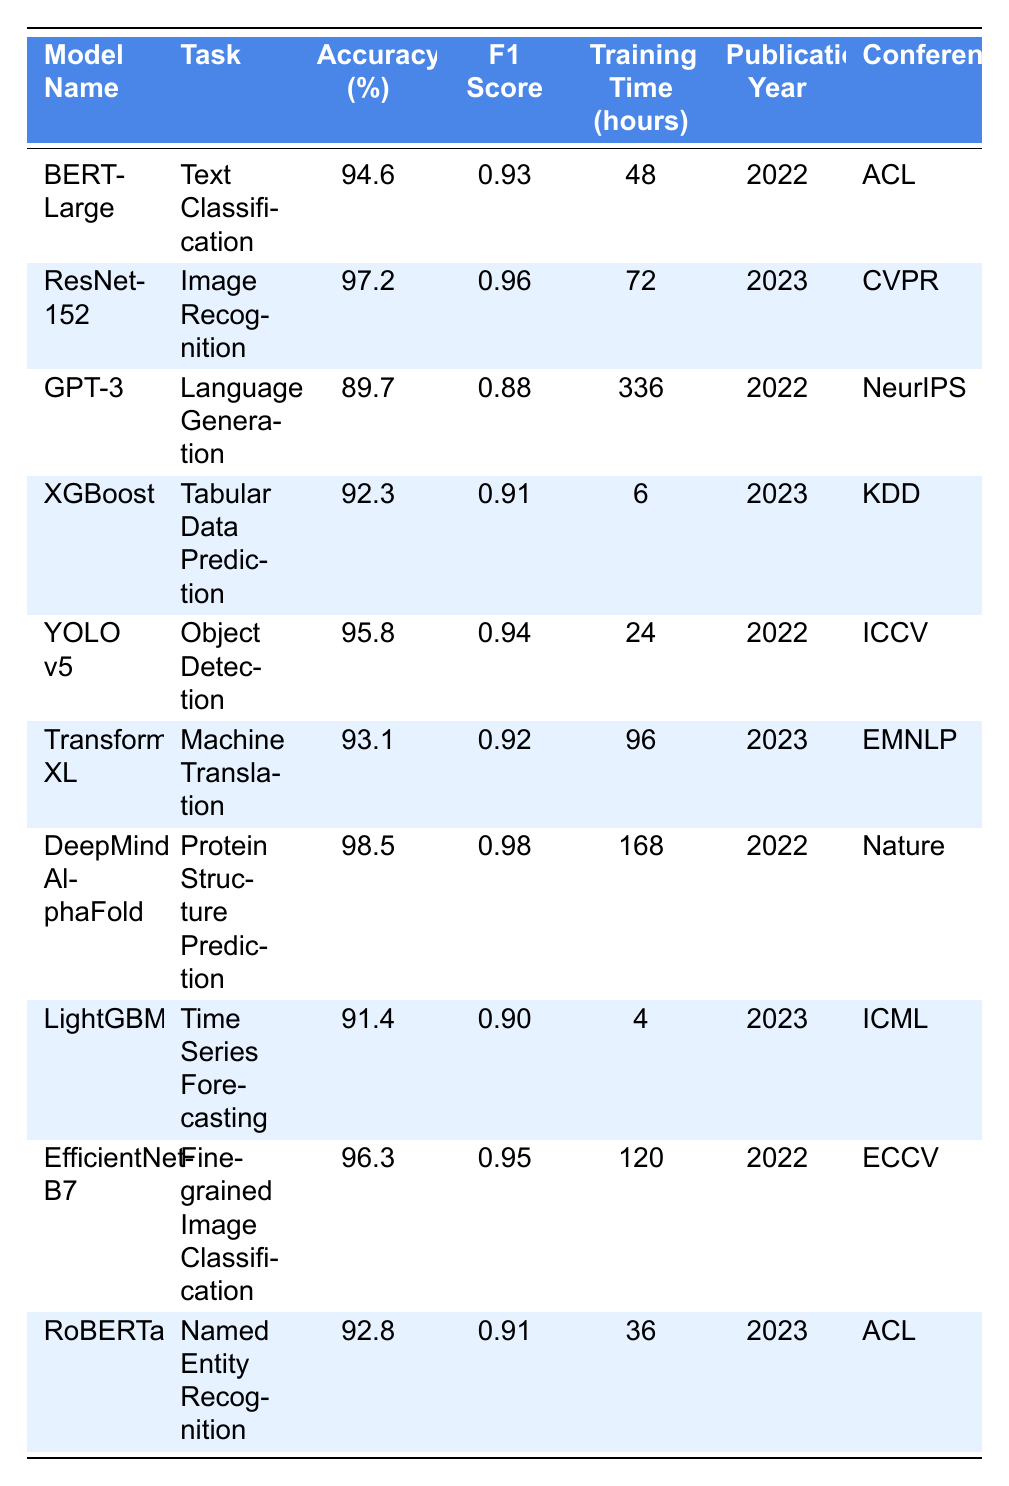What model had the highest accuracy? The models listed in the table are compared by their accuracy values. DeepMind AlphaFold has an accuracy of 98.5%, which is higher than all other models.
Answer: DeepMind AlphaFold Which model took the longest time to train? Training times for each model are compared, and GPT-3 has the highest training time at 336 hours.
Answer: GPT-3 Is ResNet-152 from a conference or journal? We look at the "Conference/Journal" column for ResNet-152, which lists CVPR, confirming it comes from a conference.
Answer: Yes What is the average F1 Score of the models used for tasks published in 2023? We find the F1 Scores for the 2023 publications: 0.96 (ResNet-152), 0.91 (XGBoost), 0.92 (Transformer-XL), and 0.91 (RoBERTa). Summing these scores gives 3.70, and there are 4 scores, so the average is 3.70 / 4 = 0.925.
Answer: 0.925 Which model achieved an accuracy of more than 95%? We examine the accuracy values for each model. The models with more than 95% accuracy are ResNet-152 (97.2%), DeepMind AlphaFold (98.5%), YOLO v5 (95.8%), and EfficientNet-B7 (96.3%).
Answer: ResNet-152, DeepMind AlphaFold, YOLO v5, EfficientNet-B7 How many models were published in 2022? Counting the rows in the table with "Publication Year" as 2022: BERT-Large, GPT-3, YOLO v5, DeepMind AlphaFold, and EfficientNet-B7 gives a total of 5 models published in 2022.
Answer: 5 Is there any model that performs under 90% accuracy? By assessing the "Accuracy (%)" column, we see GPT-3 with 89.7% accuracy, indicating it is the only model below 90%.
Answer: Yes What is the difference in training time between the model with the highest accuracy and the model with the lowest accuracy? DeepMind AlphaFold has the highest accuracy and takes 168 hours to train, while GPT-3 has the lowest accuracy and takes 336 hours. The difference is 336 - 168 = 168 hours.
Answer: 168 hours How many different tasks are represented in the table? We check the "Task" column for unique entries: Text Classification, Image Recognition, Language Generation, Tabular Data Prediction, Object Detection, Machine Translation, Protein Structure Prediction, Time Series Forecasting, Fine-grained Image Classification, and Named Entity Recognition. This gives us 10 distinct tasks.
Answer: 10 Which model published in 2023 has the shortest training time? Among the models published in 2023, we check the training times: ResNet-152 (72), XGBoost (6), Transformer-XL (96), and RoBERTa (36). The shortest training time is for XGBoost at 6 hours.
Answer: XGBoost 